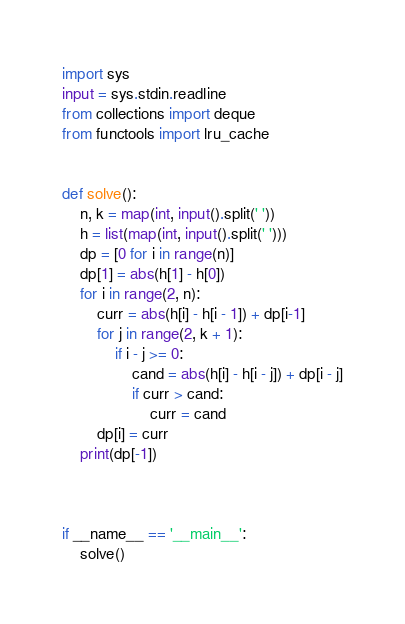Convert code to text. <code><loc_0><loc_0><loc_500><loc_500><_Python_>import sys
input = sys.stdin.readline
from collections import deque
from functools import lru_cache


def solve():
    n, k = map(int, input().split(' '))
    h = list(map(int, input().split(' ')))
    dp = [0 for i in range(n)]
    dp[1] = abs(h[1] - h[0])
    for i in range(2, n):
        curr = abs(h[i] - h[i - 1]) + dp[i-1]
        for j in range(2, k + 1):
            if i - j >= 0:
                cand = abs(h[i] - h[i - j]) + dp[i - j]
                if curr > cand:
                    curr = cand
        dp[i] = curr
    print(dp[-1])
    


if __name__ == '__main__':
    solve()</code> 